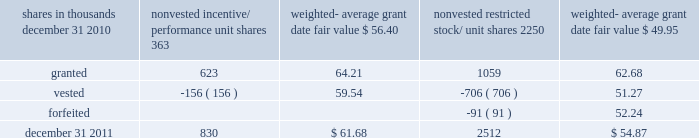There were no options granted in excess of market value in 2011 , 2010 or 2009 .
Shares of common stock available during the next year for the granting of options and other awards under the incentive plans were 33775543 at december 31 , 2011 .
Total shares of pnc common stock authorized for future issuance under equity compensation plans totaled 35304422 shares at december 31 , 2011 , which includes shares available for issuance under the incentive plans and the employee stock purchase plan ( espp ) as described below .
During 2011 , we issued 731336 shares from treasury stock in connection with stock option exercise activity .
As with past exercise activity , we currently intend to utilize primarily treasury stock for any future stock option exercises .
Awards granted to non-employee directors in 2011 , 2010 and 2009 include 27090 , 29040 , and 39552 deferred stock units , respectively , awarded under the outside directors deferred stock unit plan .
A deferred stock unit is a phantom share of our common stock , which requires liability accounting treatment until such awards are paid to the participants as cash .
As there are no vesting or service requirements on these awards , total compensation expense is recognized in full on awarded deferred stock units on the date of grant .
Incentive/performance unit share awards and restricted stock/unit awards the fair value of nonvested incentive/performance unit share awards and restricted stock/unit awards is initially determined based on prices not less than the market value of our common stock price on the date of grant .
The value of certain incentive/ performance unit share awards is subsequently remeasured based on the achievement of one or more financial and other performance goals generally over a three-year period .
The personnel and compensation committee of the board of directors approves the final award payout with respect to incentive/performance unit share awards .
Restricted stock/unit awards have various vesting periods generally ranging from 36 months to 60 months .
Beginning in 2011 , we incorporated two changes to certain awards under our existing long-term incentive compensation programs .
First , for certain grants of incentive performance units , the future payout amount will be subject to a negative annual adjustment if pnc fails to meet certain risk-related performance metrics .
This adjustment is in addition to the existing financial performance metrics relative to our peers .
These grants have a three-year performance period and are payable in either stock or a combination of stock and cash .
Second , performance-based restricted share units ( performance rsus ) were granted in 2011 to certain of our executives in lieu of stock options .
These performance rsus ( which are payable solely in stock ) have a service condition , an internal risk-related performance condition , and an external market condition .
Satisfaction of the performance condition is based on four independent one-year performance periods .
The weighted-average grant-date fair value of incentive/ performance unit share awards and restricted stock/unit awards granted in 2011 , 2010 and 2009 was $ 63.25 , $ 54.59 and $ 41.16 per share , respectively .
We recognize compensation expense for such awards ratably over the corresponding vesting and/or performance periods for each type of program .
Nonvested incentive/performance unit share awards and restricted stock/unit awards 2013 rollforward shares in thousands nonvested incentive/ performance unit shares weighted- average date fair nonvested restricted stock/ shares weighted- average date fair .
In the chart above , the unit shares and related weighted- average grant-date fair value of the incentive/performance awards exclude the effect of dividends on the underlying shares , as those dividends will be paid in cash .
At december 31 , 2011 , there was $ 61 million of unrecognized deferred compensation expense related to nonvested share- based compensation arrangements granted under the incentive plans .
This cost is expected to be recognized as expense over a period of no longer than five years .
The total fair value of incentive/performance unit share and restricted stock/unit awards vested during 2011 , 2010 and 2009 was approximately $ 52 million , $ 39 million and $ 47 million , respectively .
Liability awards we grant annually cash-payable restricted share units to certain executives .
The grants were made primarily as part of an annual bonus incentive deferral plan .
While there are time- based and service-related vesting criteria , there are no market or performance criteria associated with these awards .
Compensation expense recognized related to these awards was recorded in prior periods as part of annual cash bonus criteria .
As of december 31 , 2011 , there were 753203 of these cash- payable restricted share units outstanding .
174 the pnc financial services group , inc .
2013 form 10-k .
If the weighted-average grant date fair value of nonvested shares increased in predictable amounts , what would the approximate value of the fair value on june 30 , 2010? 
Computations: (((61.68 - 56.40) / 2) + 56.40)
Answer: 59.04. 